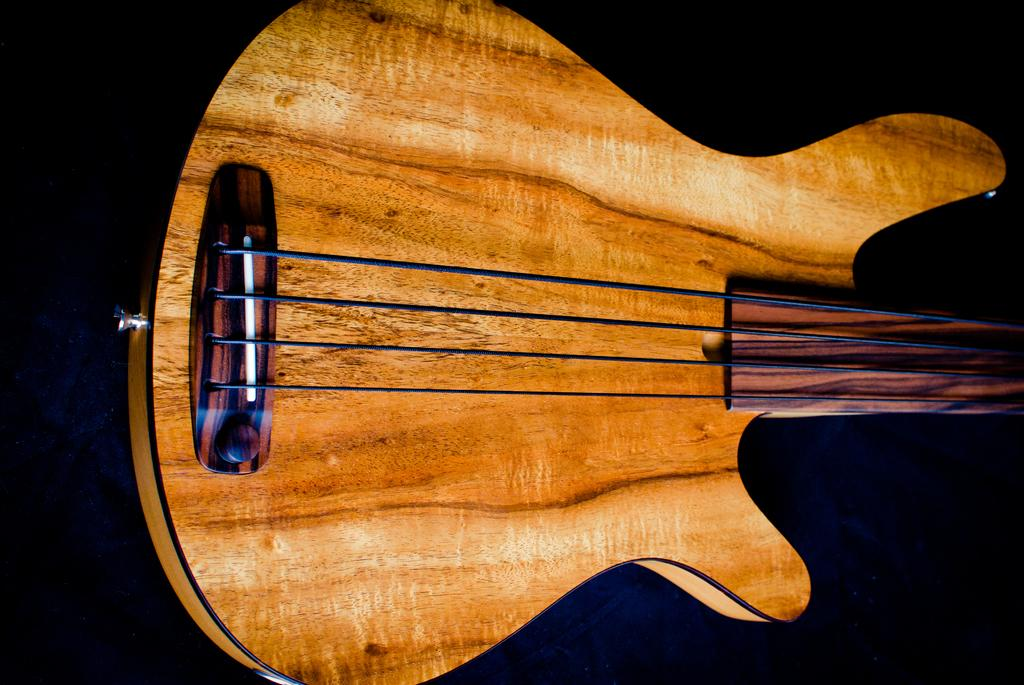What type of object is the main subject in the image? There is a music instrument in the image. What color is the music instrument? The music instrument is yellow. What feature can be seen on the music instrument? There are black strings on the music instrument. What can be seen in the background of the image? There is a black wall in the background of the image. What direction is the kitten facing in the image? There is no kitten present in the image. What date is circled on the calendar in the image? There is no calendar present in the image. 